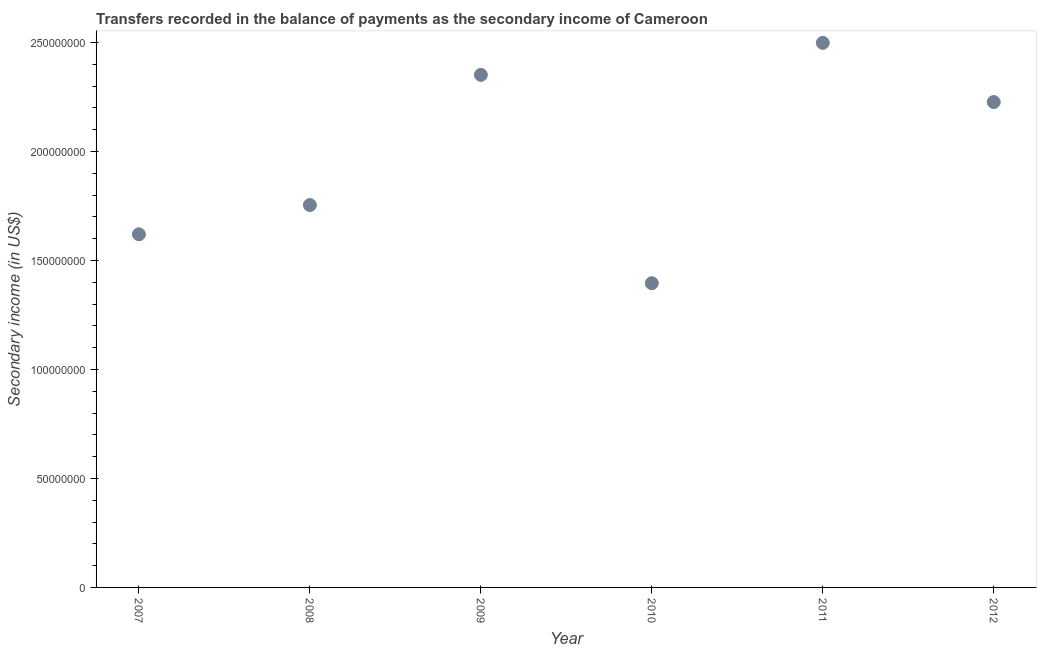What is the amount of secondary income in 2008?
Your answer should be very brief. 1.75e+08. Across all years, what is the maximum amount of secondary income?
Provide a succinct answer. 2.50e+08. Across all years, what is the minimum amount of secondary income?
Provide a succinct answer. 1.40e+08. What is the sum of the amount of secondary income?
Your response must be concise. 1.18e+09. What is the difference between the amount of secondary income in 2008 and 2009?
Ensure brevity in your answer.  -5.97e+07. What is the average amount of secondary income per year?
Make the answer very short. 1.97e+08. What is the median amount of secondary income?
Your answer should be very brief. 1.99e+08. Do a majority of the years between 2009 and 2011 (inclusive) have amount of secondary income greater than 40000000 US$?
Give a very brief answer. Yes. What is the ratio of the amount of secondary income in 2008 to that in 2012?
Give a very brief answer. 0.79. What is the difference between the highest and the second highest amount of secondary income?
Your answer should be very brief. 1.47e+07. Is the sum of the amount of secondary income in 2007 and 2009 greater than the maximum amount of secondary income across all years?
Your answer should be very brief. Yes. What is the difference between the highest and the lowest amount of secondary income?
Your response must be concise. 1.10e+08. In how many years, is the amount of secondary income greater than the average amount of secondary income taken over all years?
Your answer should be very brief. 3. Does the amount of secondary income monotonically increase over the years?
Provide a succinct answer. No. What is the difference between two consecutive major ticks on the Y-axis?
Your response must be concise. 5.00e+07. Does the graph contain any zero values?
Keep it short and to the point. No. What is the title of the graph?
Ensure brevity in your answer.  Transfers recorded in the balance of payments as the secondary income of Cameroon. What is the label or title of the X-axis?
Make the answer very short. Year. What is the label or title of the Y-axis?
Offer a very short reply. Secondary income (in US$). What is the Secondary income (in US$) in 2007?
Provide a short and direct response. 1.62e+08. What is the Secondary income (in US$) in 2008?
Keep it short and to the point. 1.75e+08. What is the Secondary income (in US$) in 2009?
Offer a terse response. 2.35e+08. What is the Secondary income (in US$) in 2010?
Keep it short and to the point. 1.40e+08. What is the Secondary income (in US$) in 2011?
Give a very brief answer. 2.50e+08. What is the Secondary income (in US$) in 2012?
Keep it short and to the point. 2.23e+08. What is the difference between the Secondary income (in US$) in 2007 and 2008?
Provide a short and direct response. -1.34e+07. What is the difference between the Secondary income (in US$) in 2007 and 2009?
Your answer should be very brief. -7.31e+07. What is the difference between the Secondary income (in US$) in 2007 and 2010?
Make the answer very short. 2.24e+07. What is the difference between the Secondary income (in US$) in 2007 and 2011?
Ensure brevity in your answer.  -8.78e+07. What is the difference between the Secondary income (in US$) in 2007 and 2012?
Ensure brevity in your answer.  -6.07e+07. What is the difference between the Secondary income (in US$) in 2008 and 2009?
Make the answer very short. -5.97e+07. What is the difference between the Secondary income (in US$) in 2008 and 2010?
Offer a very short reply. 3.59e+07. What is the difference between the Secondary income (in US$) in 2008 and 2011?
Provide a succinct answer. -7.44e+07. What is the difference between the Secondary income (in US$) in 2008 and 2012?
Provide a succinct answer. -4.72e+07. What is the difference between the Secondary income (in US$) in 2009 and 2010?
Provide a succinct answer. 9.56e+07. What is the difference between the Secondary income (in US$) in 2009 and 2011?
Make the answer very short. -1.47e+07. What is the difference between the Secondary income (in US$) in 2009 and 2012?
Offer a very short reply. 1.25e+07. What is the difference between the Secondary income (in US$) in 2010 and 2011?
Provide a succinct answer. -1.10e+08. What is the difference between the Secondary income (in US$) in 2010 and 2012?
Keep it short and to the point. -8.31e+07. What is the difference between the Secondary income (in US$) in 2011 and 2012?
Ensure brevity in your answer.  2.71e+07. What is the ratio of the Secondary income (in US$) in 2007 to that in 2008?
Give a very brief answer. 0.92. What is the ratio of the Secondary income (in US$) in 2007 to that in 2009?
Provide a succinct answer. 0.69. What is the ratio of the Secondary income (in US$) in 2007 to that in 2010?
Provide a succinct answer. 1.16. What is the ratio of the Secondary income (in US$) in 2007 to that in 2011?
Offer a very short reply. 0.65. What is the ratio of the Secondary income (in US$) in 2007 to that in 2012?
Give a very brief answer. 0.73. What is the ratio of the Secondary income (in US$) in 2008 to that in 2009?
Offer a very short reply. 0.75. What is the ratio of the Secondary income (in US$) in 2008 to that in 2010?
Offer a very short reply. 1.26. What is the ratio of the Secondary income (in US$) in 2008 to that in 2011?
Offer a very short reply. 0.7. What is the ratio of the Secondary income (in US$) in 2008 to that in 2012?
Keep it short and to the point. 0.79. What is the ratio of the Secondary income (in US$) in 2009 to that in 2010?
Your response must be concise. 1.69. What is the ratio of the Secondary income (in US$) in 2009 to that in 2011?
Offer a very short reply. 0.94. What is the ratio of the Secondary income (in US$) in 2009 to that in 2012?
Provide a short and direct response. 1.06. What is the ratio of the Secondary income (in US$) in 2010 to that in 2011?
Keep it short and to the point. 0.56. What is the ratio of the Secondary income (in US$) in 2010 to that in 2012?
Your response must be concise. 0.63. What is the ratio of the Secondary income (in US$) in 2011 to that in 2012?
Give a very brief answer. 1.12. 